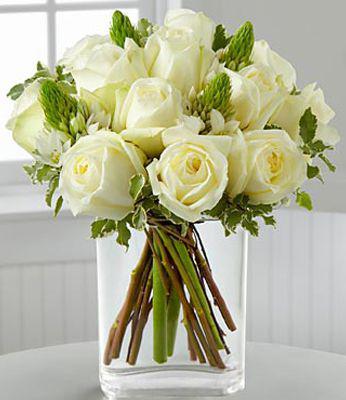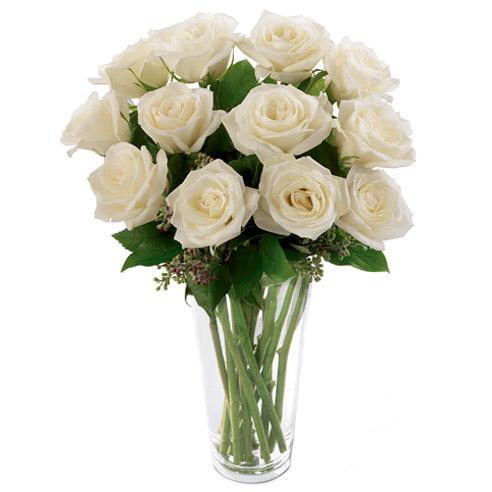The first image is the image on the left, the second image is the image on the right. Examine the images to the left and right. Is the description "There are a total of 6 red roses." accurate? Answer yes or no. No. 